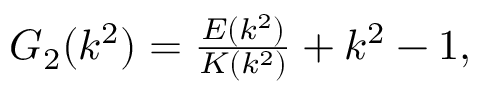<formula> <loc_0><loc_0><loc_500><loc_500>\begin{array} { r } { G _ { 2 } ( k ^ { 2 } ) = \frac { E ( k ^ { 2 } ) } { K ( k ^ { 2 } ) } + k ^ { 2 } - 1 , } \end{array}</formula> 